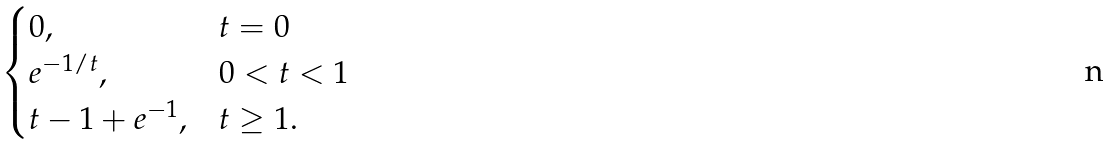<formula> <loc_0><loc_0><loc_500><loc_500>\begin{cases} 0 , & t = 0 \\ e ^ { - 1 / t } , & 0 < t < 1 \\ t - 1 + e ^ { - 1 } , & t \geq 1 . \end{cases}</formula> 